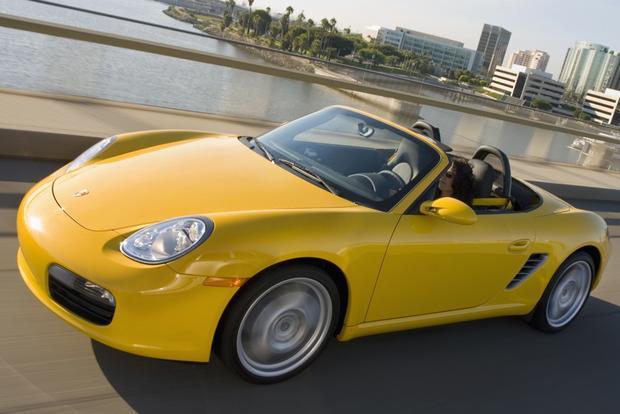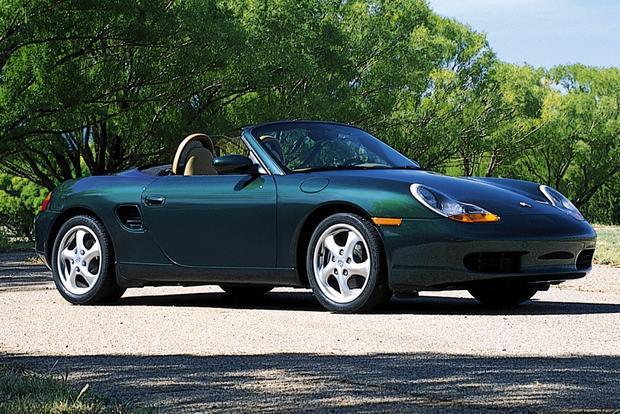The first image is the image on the left, the second image is the image on the right. Evaluate the accuracy of this statement regarding the images: "there is a car parked on the street in front of a house". Is it true? Answer yes or no. No. The first image is the image on the left, the second image is the image on the right. Given the left and right images, does the statement "There is 1 or more silver cars on the road." hold true? Answer yes or no. No. 